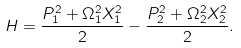<formula> <loc_0><loc_0><loc_500><loc_500>H = \frac { P _ { 1 } ^ { 2 } + \Omega _ { 1 } ^ { 2 } X _ { 1 } ^ { 2 } } 2 - \frac { P _ { 2 } ^ { 2 } + \Omega _ { 2 } ^ { 2 } X _ { 2 } ^ { 2 } } 2 .</formula> 